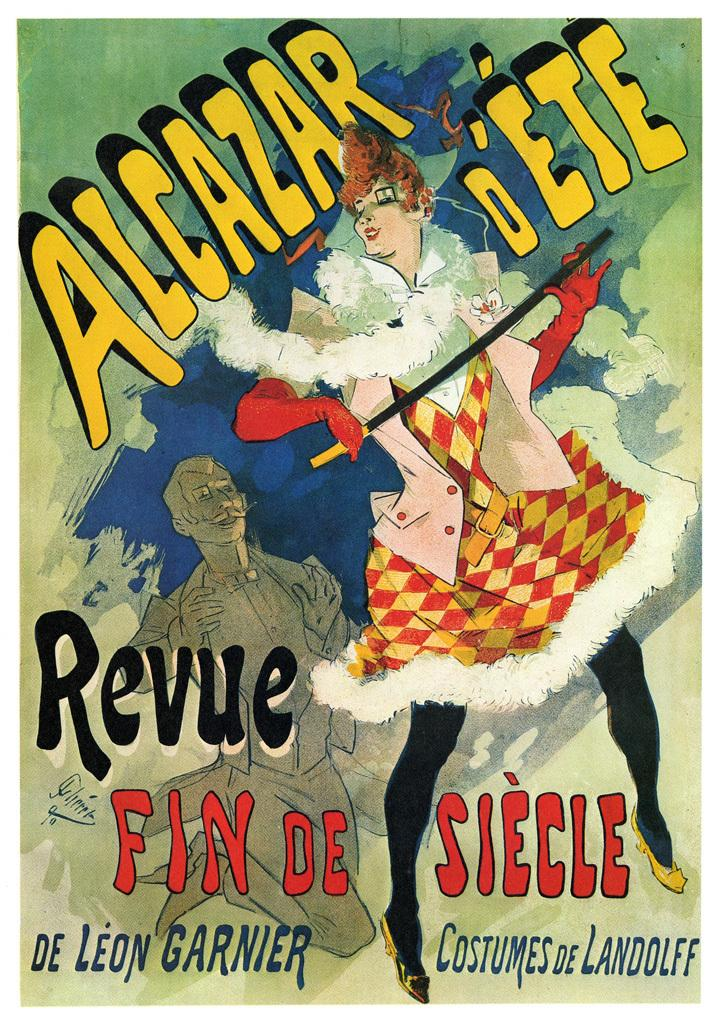<image>
Render a clear and concise summary of the photo. An old animated advertisement for Alcarzar D'Ete shows a woman in a checkered dress holding a sword while a man claps. 